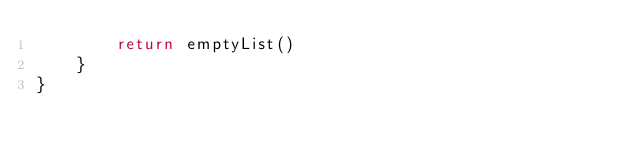<code> <loc_0><loc_0><loc_500><loc_500><_Kotlin_>        return emptyList()
    }
}
</code> 